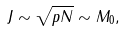Convert formula to latex. <formula><loc_0><loc_0><loc_500><loc_500>J \sim \sqrt { p N } \sim M _ { 0 } ,</formula> 